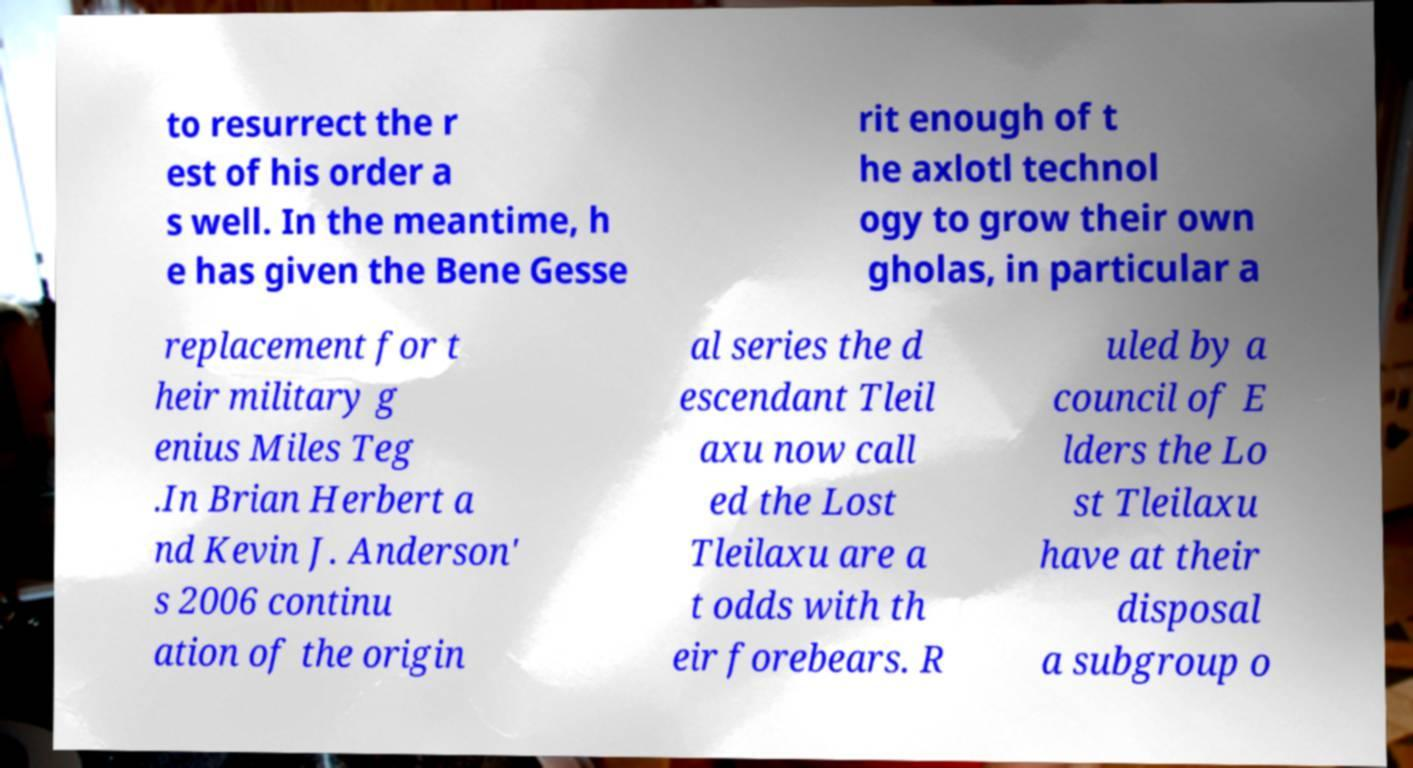Please identify and transcribe the text found in this image. to resurrect the r est of his order a s well. In the meantime, h e has given the Bene Gesse rit enough of t he axlotl technol ogy to grow their own gholas, in particular a replacement for t heir military g enius Miles Teg .In Brian Herbert a nd Kevin J. Anderson' s 2006 continu ation of the origin al series the d escendant Tleil axu now call ed the Lost Tleilaxu are a t odds with th eir forebears. R uled by a council of E lders the Lo st Tleilaxu have at their disposal a subgroup o 